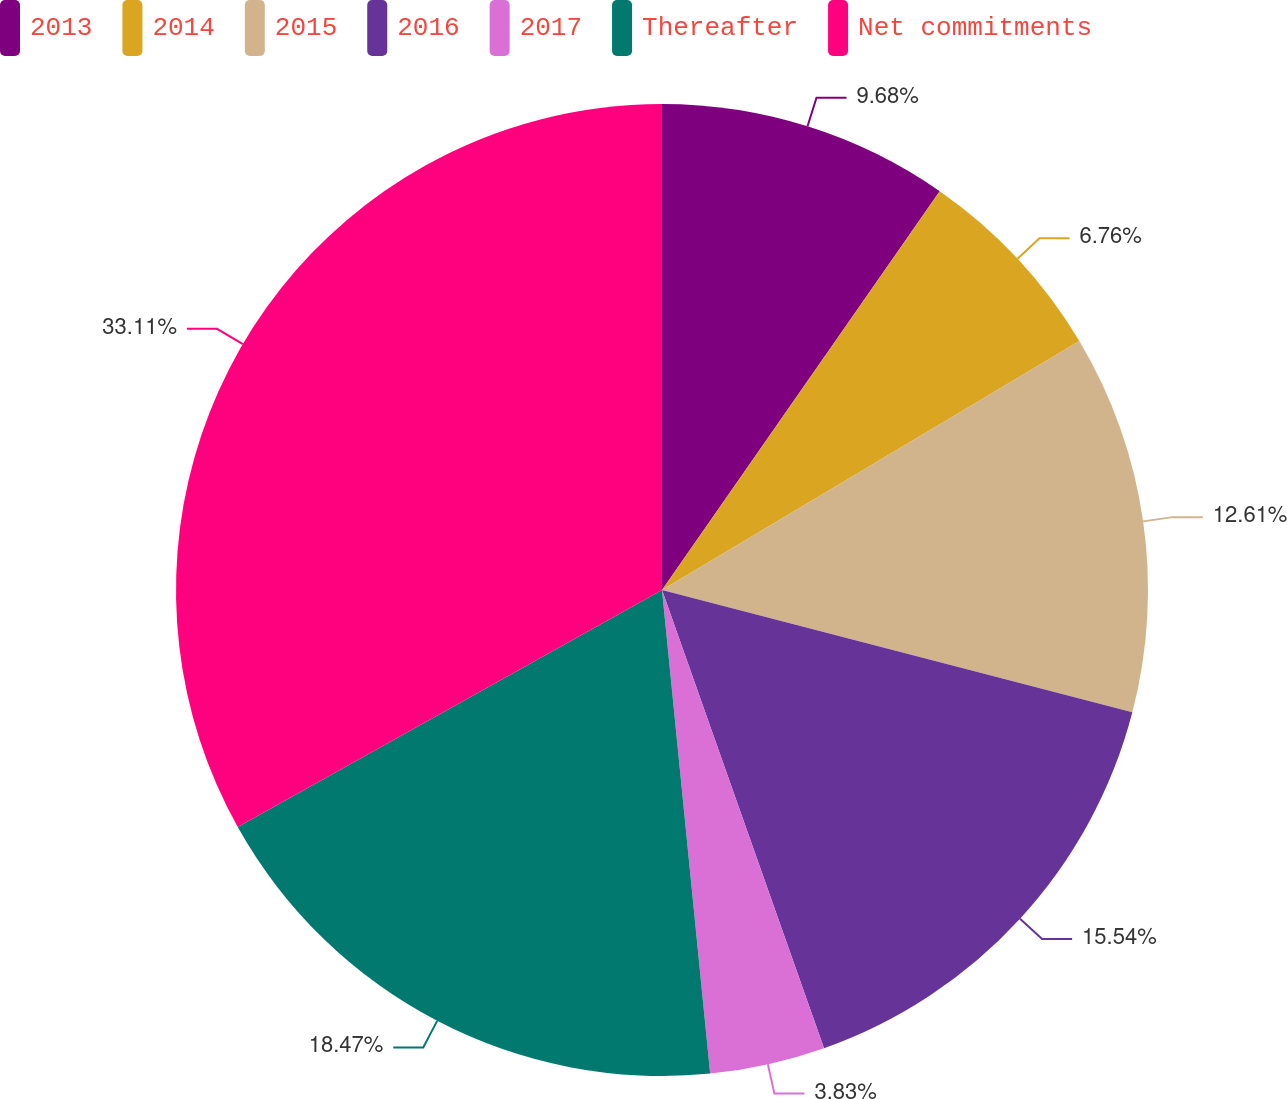Convert chart to OTSL. <chart><loc_0><loc_0><loc_500><loc_500><pie_chart><fcel>2013<fcel>2014<fcel>2015<fcel>2016<fcel>2017<fcel>Thereafter<fcel>Net commitments<nl><fcel>9.68%<fcel>6.76%<fcel>12.61%<fcel>15.54%<fcel>3.83%<fcel>18.47%<fcel>33.11%<nl></chart> 